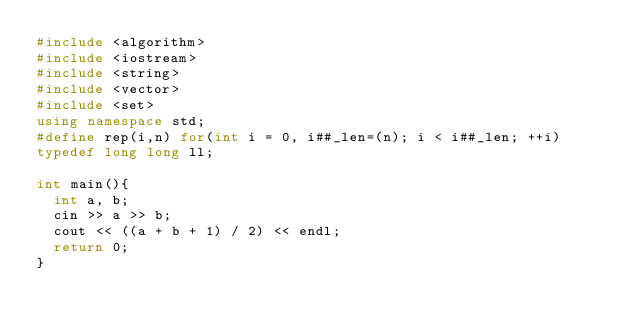Convert code to text. <code><loc_0><loc_0><loc_500><loc_500><_C++_>#include <algorithm>
#include <iostream>
#include <string>
#include <vector>
#include <set>
using namespace std;
#define rep(i,n) for(int i = 0, i##_len=(n); i < i##_len; ++i)
typedef long long ll;

int main(){
	int a, b;
	cin >> a >> b;
	cout << ((a + b + 1) / 2) << endl;
	return 0;
}
</code> 